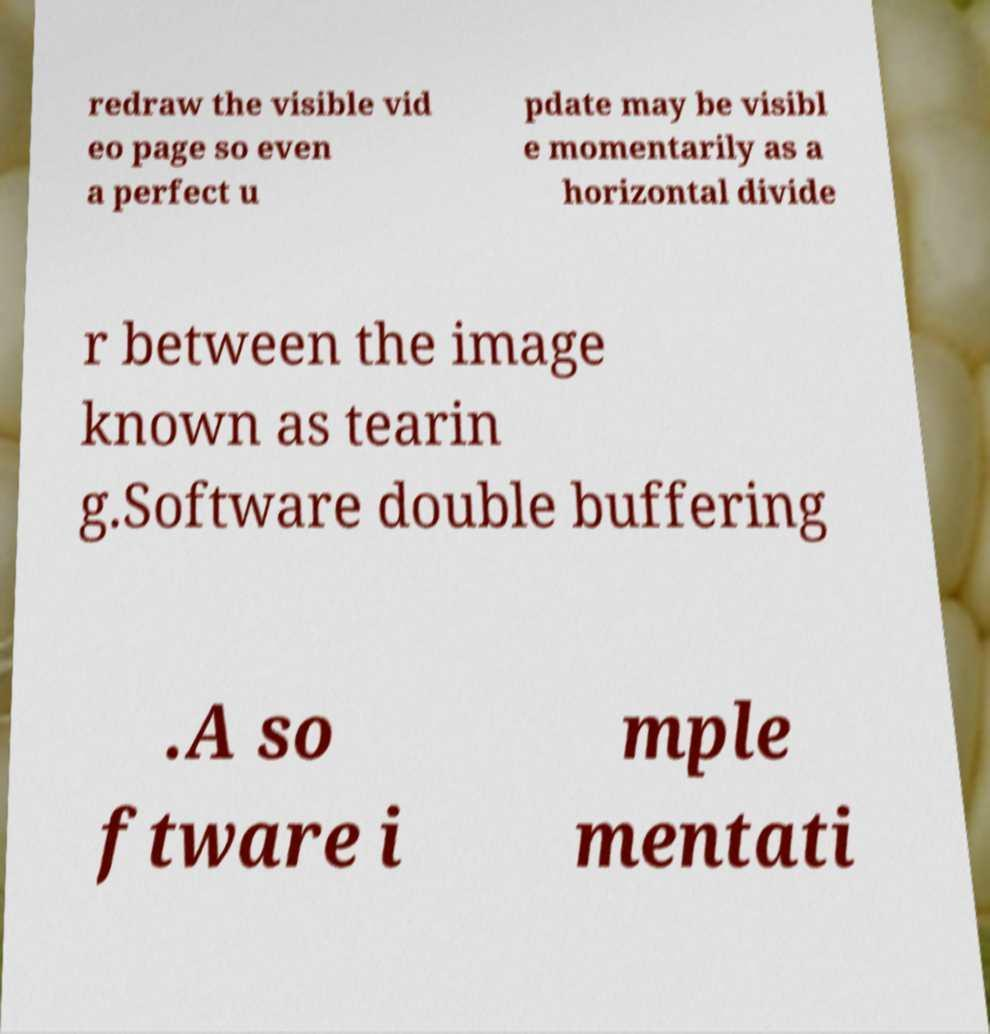Could you extract and type out the text from this image? redraw the visible vid eo page so even a perfect u pdate may be visibl e momentarily as a horizontal divide r between the image known as tearin g.Software double buffering .A so ftware i mple mentati 